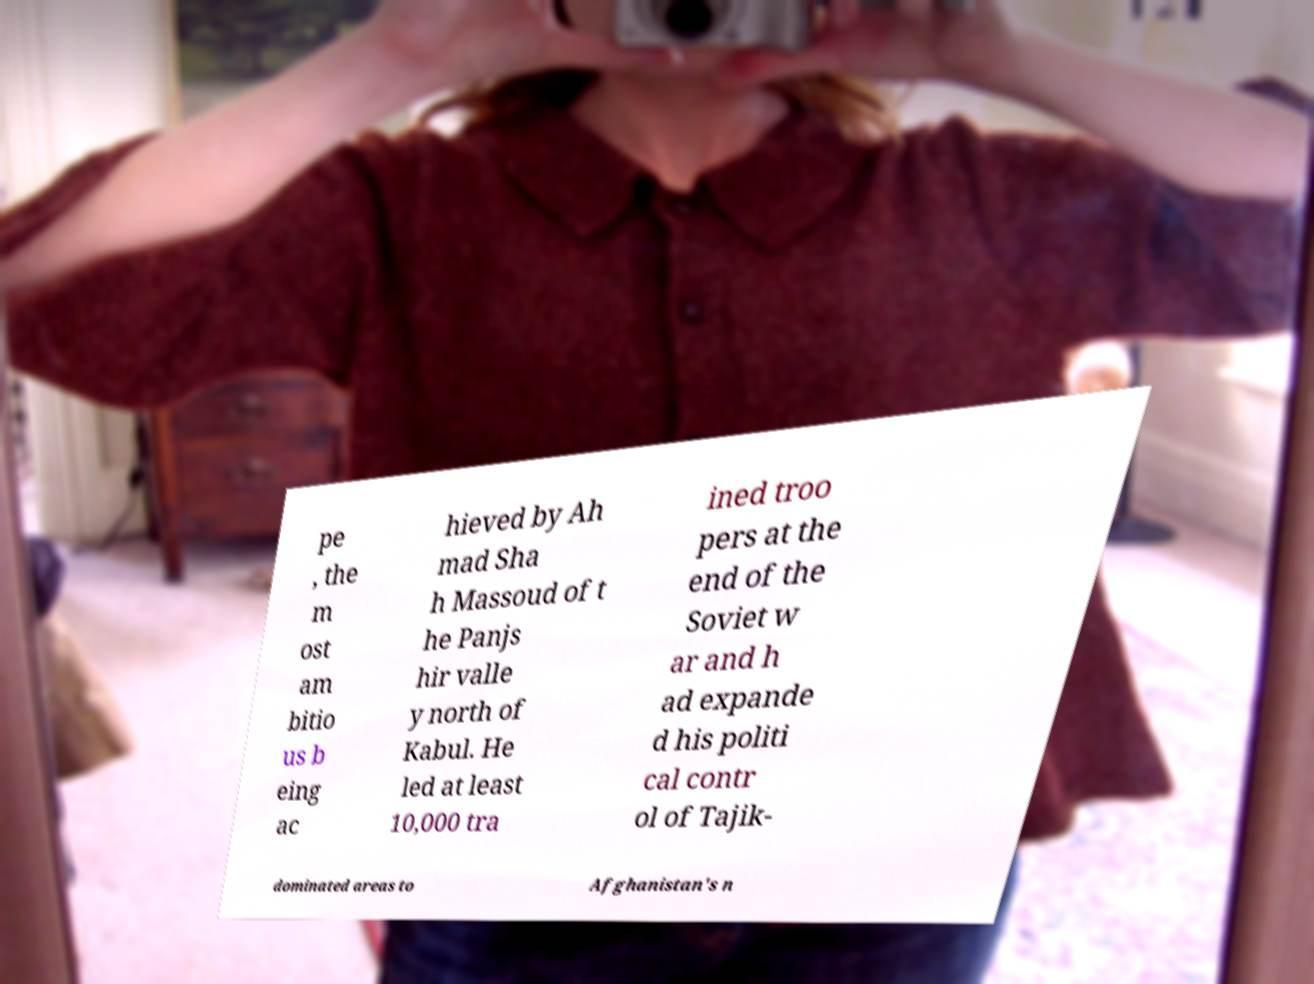I need the written content from this picture converted into text. Can you do that? pe , the m ost am bitio us b eing ac hieved by Ah mad Sha h Massoud of t he Panjs hir valle y north of Kabul. He led at least 10,000 tra ined troo pers at the end of the Soviet w ar and h ad expande d his politi cal contr ol of Tajik- dominated areas to Afghanistan's n 